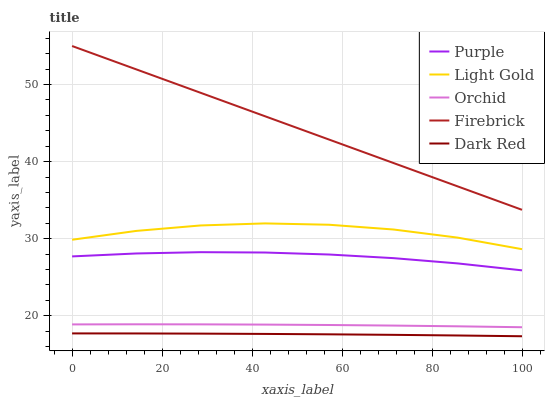Does Dark Red have the minimum area under the curve?
Answer yes or no. Yes. Does Firebrick have the maximum area under the curve?
Answer yes or no. Yes. Does Firebrick have the minimum area under the curve?
Answer yes or no. No. Does Dark Red have the maximum area under the curve?
Answer yes or no. No. Is Firebrick the smoothest?
Answer yes or no. Yes. Is Light Gold the roughest?
Answer yes or no. Yes. Is Dark Red the smoothest?
Answer yes or no. No. Is Dark Red the roughest?
Answer yes or no. No. Does Dark Red have the lowest value?
Answer yes or no. Yes. Does Firebrick have the lowest value?
Answer yes or no. No. Does Firebrick have the highest value?
Answer yes or no. Yes. Does Dark Red have the highest value?
Answer yes or no. No. Is Dark Red less than Light Gold?
Answer yes or no. Yes. Is Light Gold greater than Dark Red?
Answer yes or no. Yes. Does Dark Red intersect Light Gold?
Answer yes or no. No. 